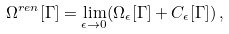Convert formula to latex. <formula><loc_0><loc_0><loc_500><loc_500>\Omega ^ { r e n } [ \Gamma ] = \lim _ { \epsilon \to 0 } ( \Omega _ { \epsilon } [ \Gamma ] + C _ { \epsilon } [ \Gamma ] ) \, ,</formula> 